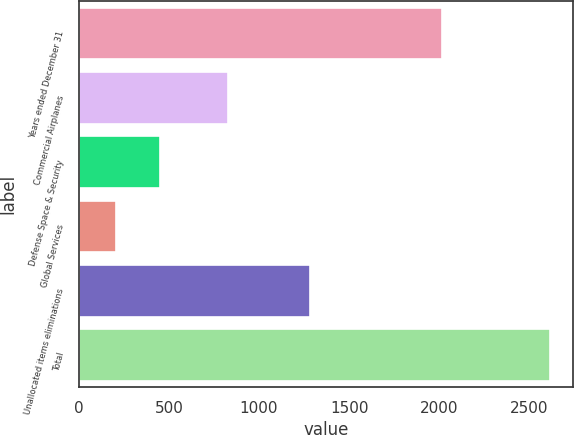Convert chart. <chart><loc_0><loc_0><loc_500><loc_500><bar_chart><fcel>Years ended December 31<fcel>Commercial Airplanes<fcel>Defense Space & Security<fcel>Global Services<fcel>Unallocated items eliminations<fcel>Total<nl><fcel>2016<fcel>830<fcel>449.4<fcel>209<fcel>1284<fcel>2613<nl></chart> 